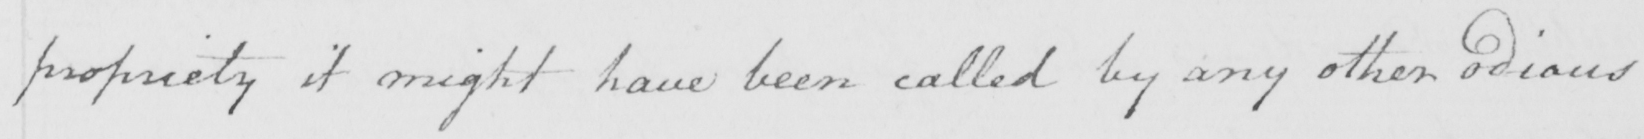Transcribe the text shown in this historical manuscript line. propriety it might have been called by any other odious 